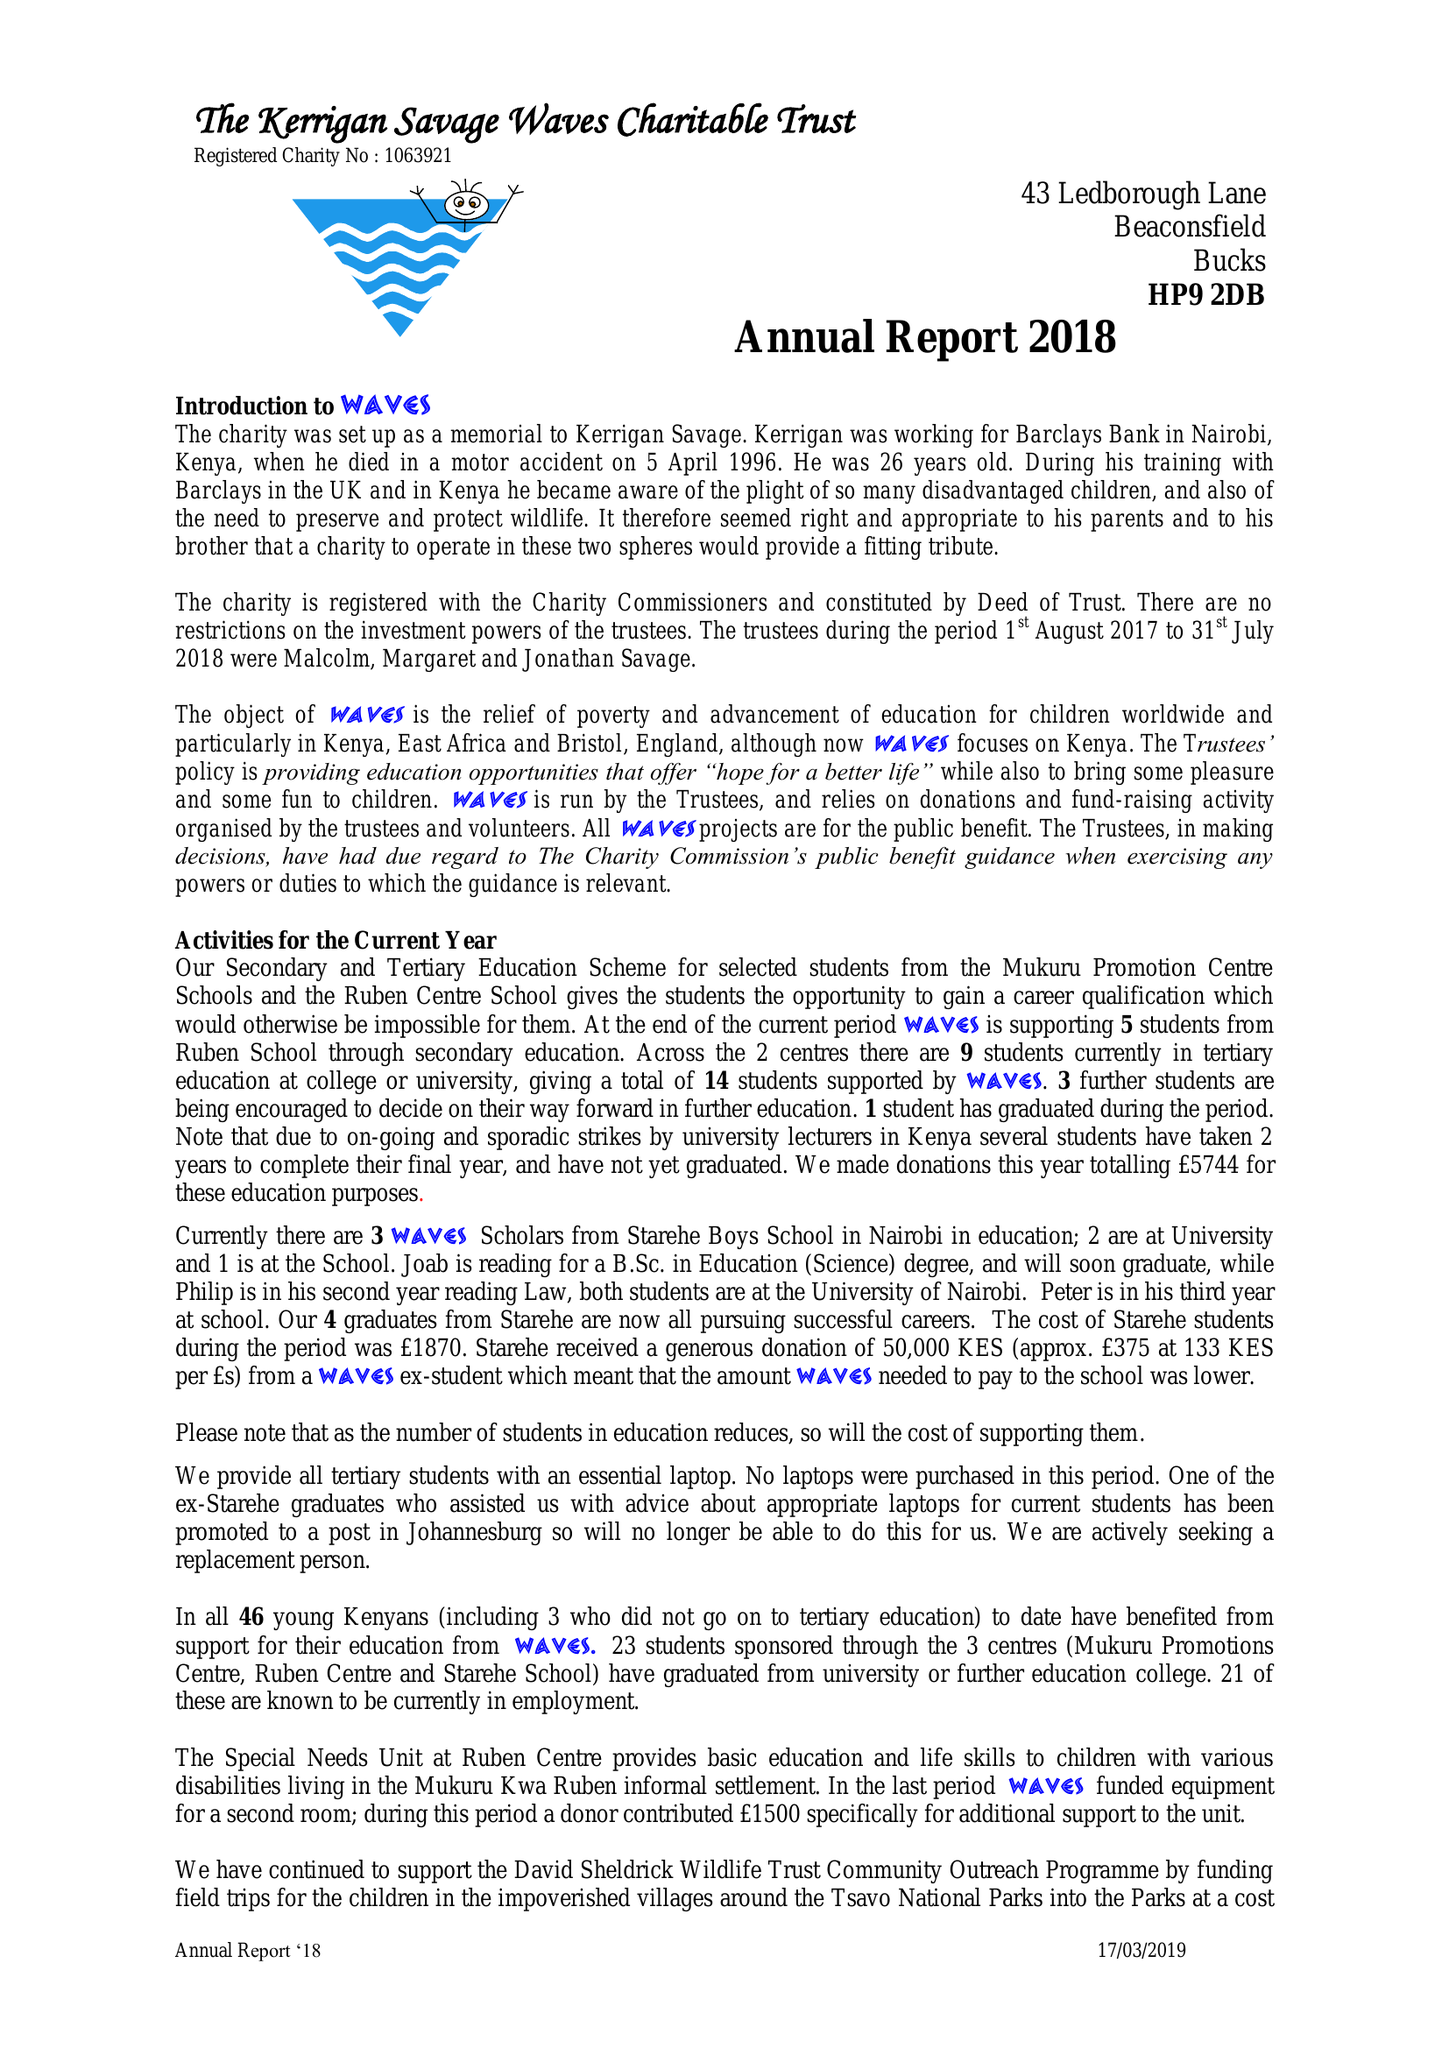What is the value for the address__postcode?
Answer the question using a single word or phrase. HP9 2DB 